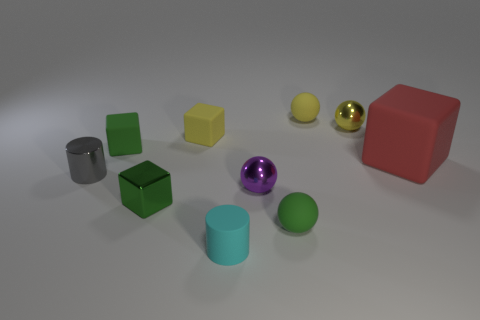Subtract all gray balls. How many green blocks are left? 2 Subtract all green balls. How many balls are left? 3 Subtract all yellow blocks. How many blocks are left? 3 Subtract all brown cubes. Subtract all red balls. How many cubes are left? 4 Subtract all cylinders. How many objects are left? 8 Subtract all big gray rubber cubes. Subtract all metal blocks. How many objects are left? 9 Add 3 small yellow matte things. How many small yellow matte things are left? 5 Add 3 rubber cylinders. How many rubber cylinders exist? 4 Subtract 0 red cylinders. How many objects are left? 10 